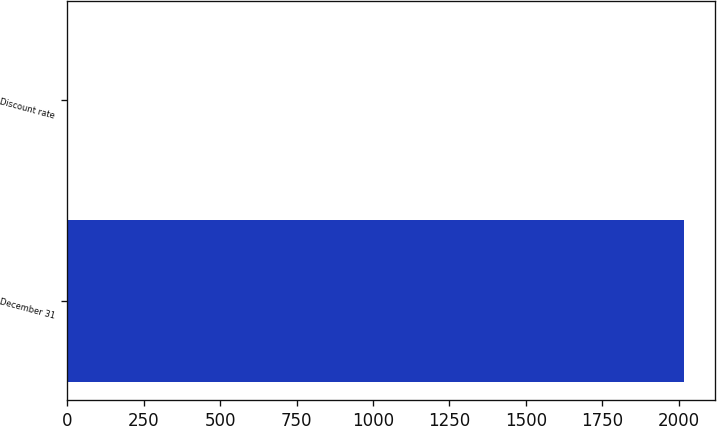Convert chart to OTSL. <chart><loc_0><loc_0><loc_500><loc_500><bar_chart><fcel>December 31<fcel>Discount rate<nl><fcel>2017<fcel>3.5<nl></chart> 